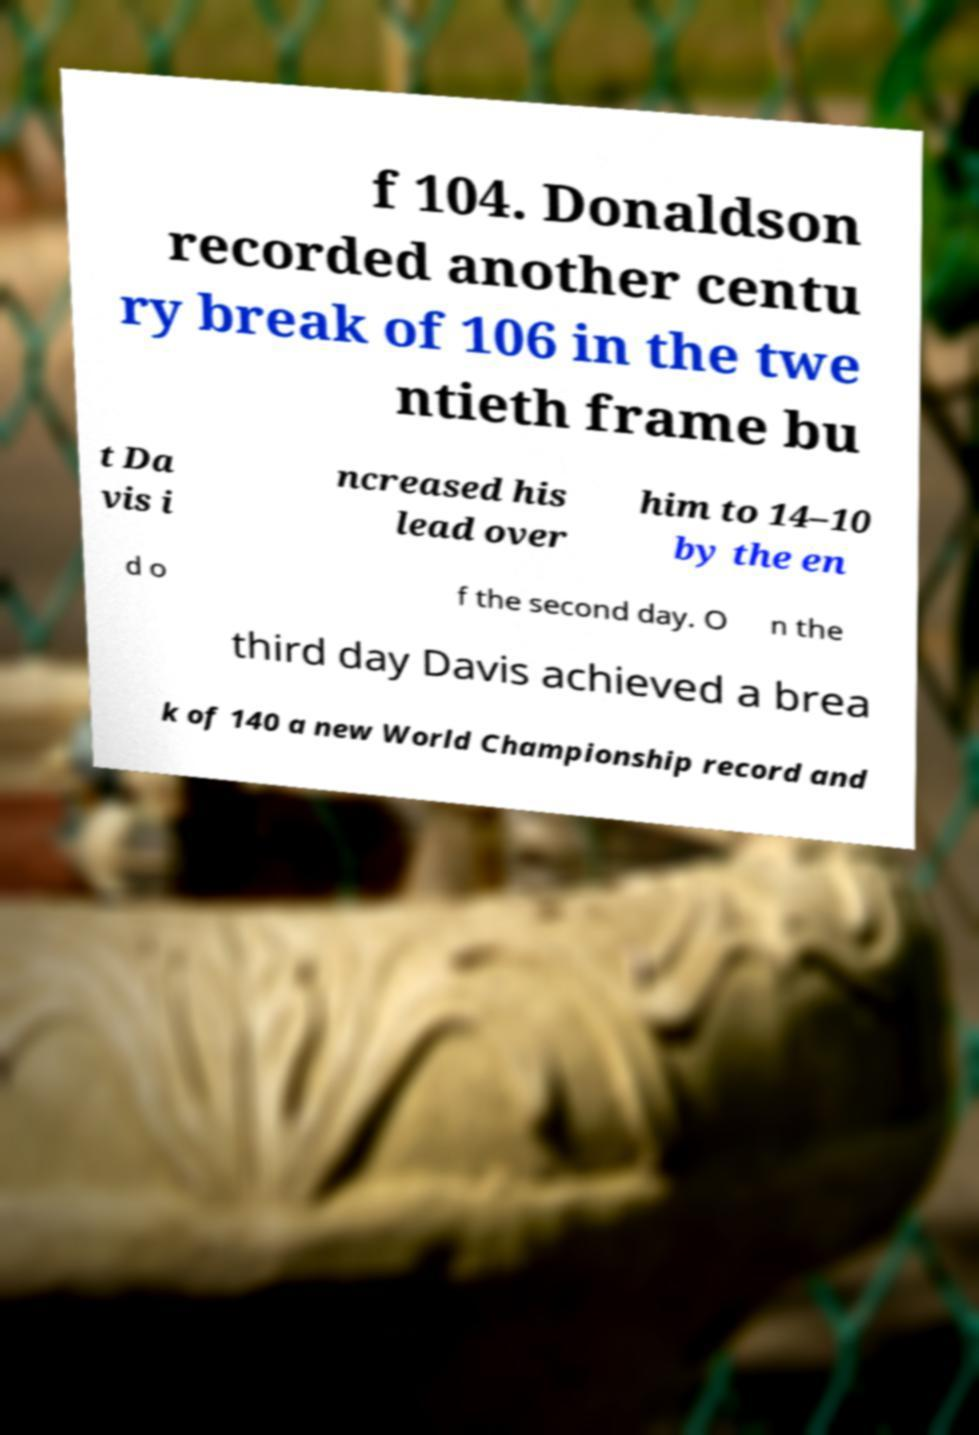I need the written content from this picture converted into text. Can you do that? f 104. Donaldson recorded another centu ry break of 106 in the twe ntieth frame bu t Da vis i ncreased his lead over him to 14–10 by the en d o f the second day. O n the third day Davis achieved a brea k of 140 a new World Championship record and 